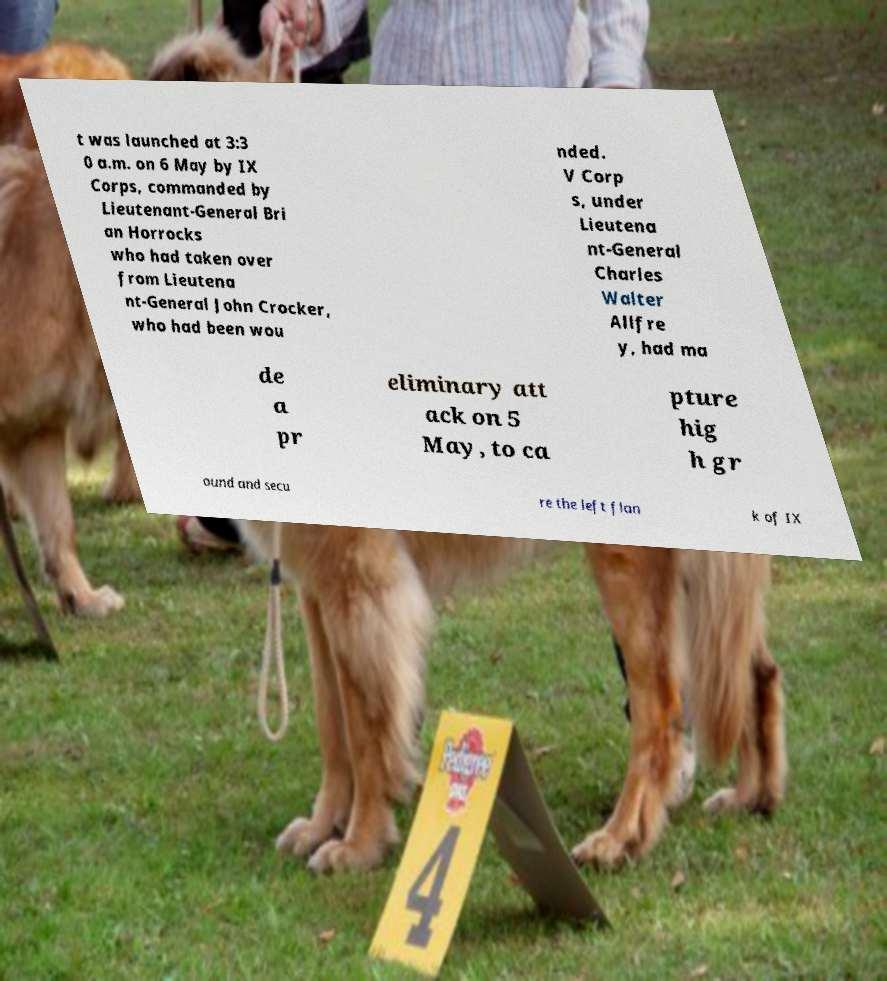Can you accurately transcribe the text from the provided image for me? t was launched at 3:3 0 a.m. on 6 May by IX Corps, commanded by Lieutenant-General Bri an Horrocks who had taken over from Lieutena nt-General John Crocker, who had been wou nded. V Corp s, under Lieutena nt-General Charles Walter Allfre y, had ma de a pr eliminary att ack on 5 May, to ca pture hig h gr ound and secu re the left flan k of IX 